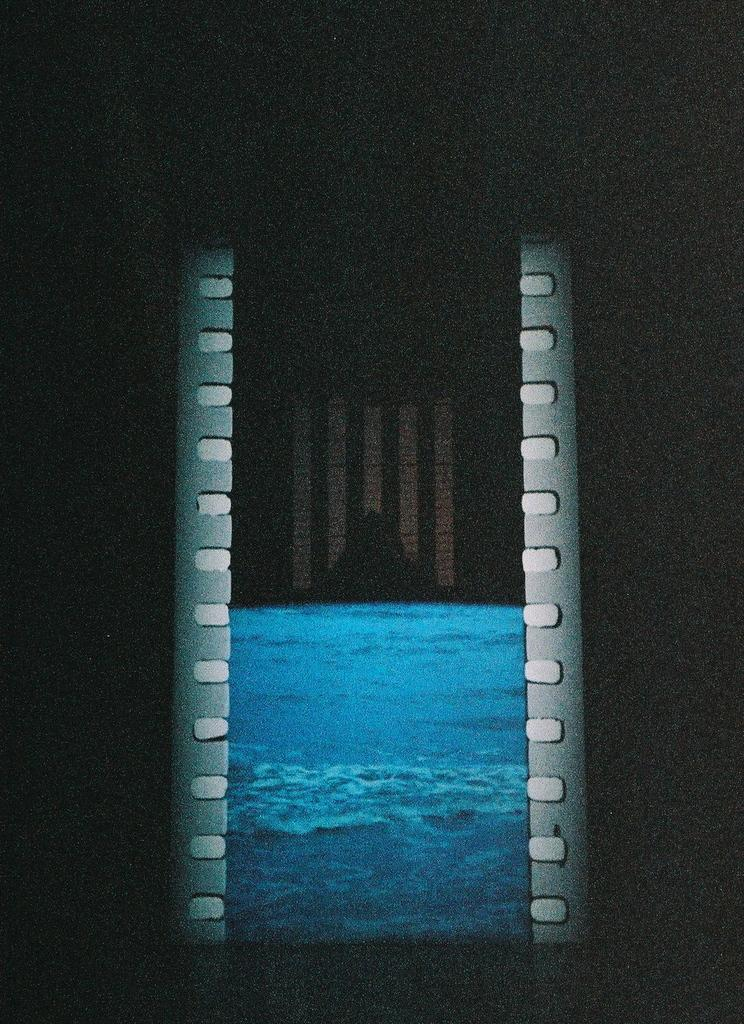What is visible in the image? Water is visible in the image. Can you describe the background of the image? The background of the image is dark. What type of answer can be seen in the image? There is no answer present in the image; it only features water and a dark background. 